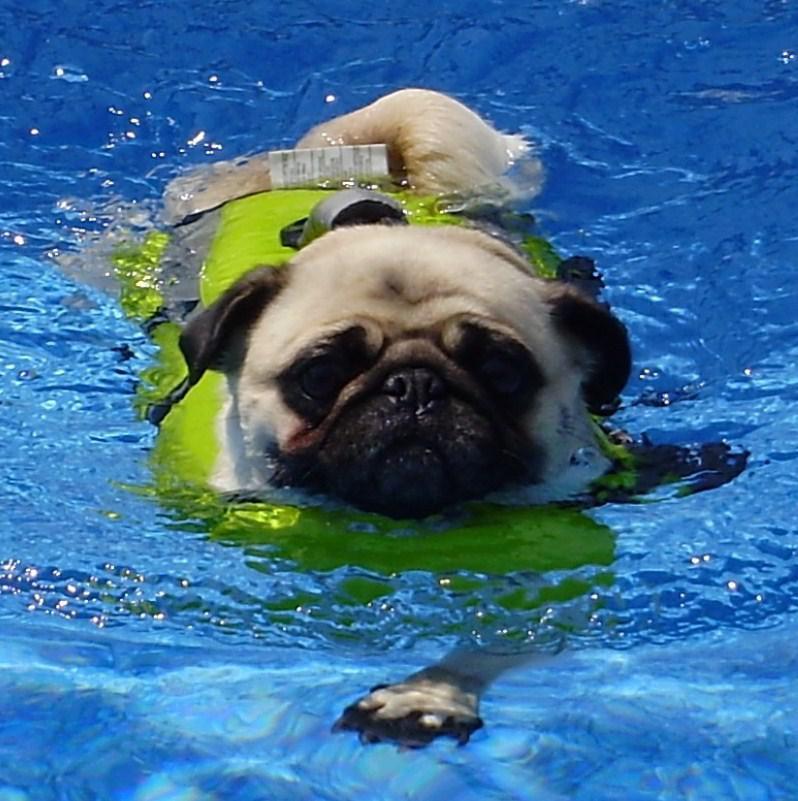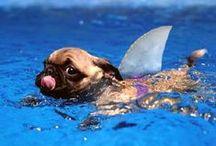The first image is the image on the left, the second image is the image on the right. Given the left and right images, does the statement "In one image a pug dog is swimming in a pool while wearing a green life jacket." hold true? Answer yes or no. Yes. 